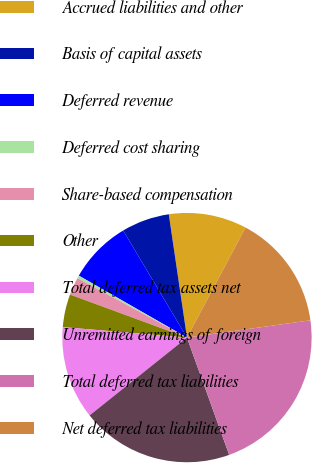<chart> <loc_0><loc_0><loc_500><loc_500><pie_chart><fcel>Accrued liabilities and other<fcel>Basis of capital assets<fcel>Deferred revenue<fcel>Deferred cost sharing<fcel>Share-based compensation<fcel>Other<fcel>Total deferred tax assets net<fcel>Unremitted earnings of foreign<fcel>Total deferred tax liabilities<fcel>Net deferred tax liabilities<nl><fcel>10.12%<fcel>6.22%<fcel>8.17%<fcel>0.36%<fcel>2.31%<fcel>4.27%<fcel>12.07%<fcel>19.77%<fcel>21.72%<fcel>15.0%<nl></chart> 